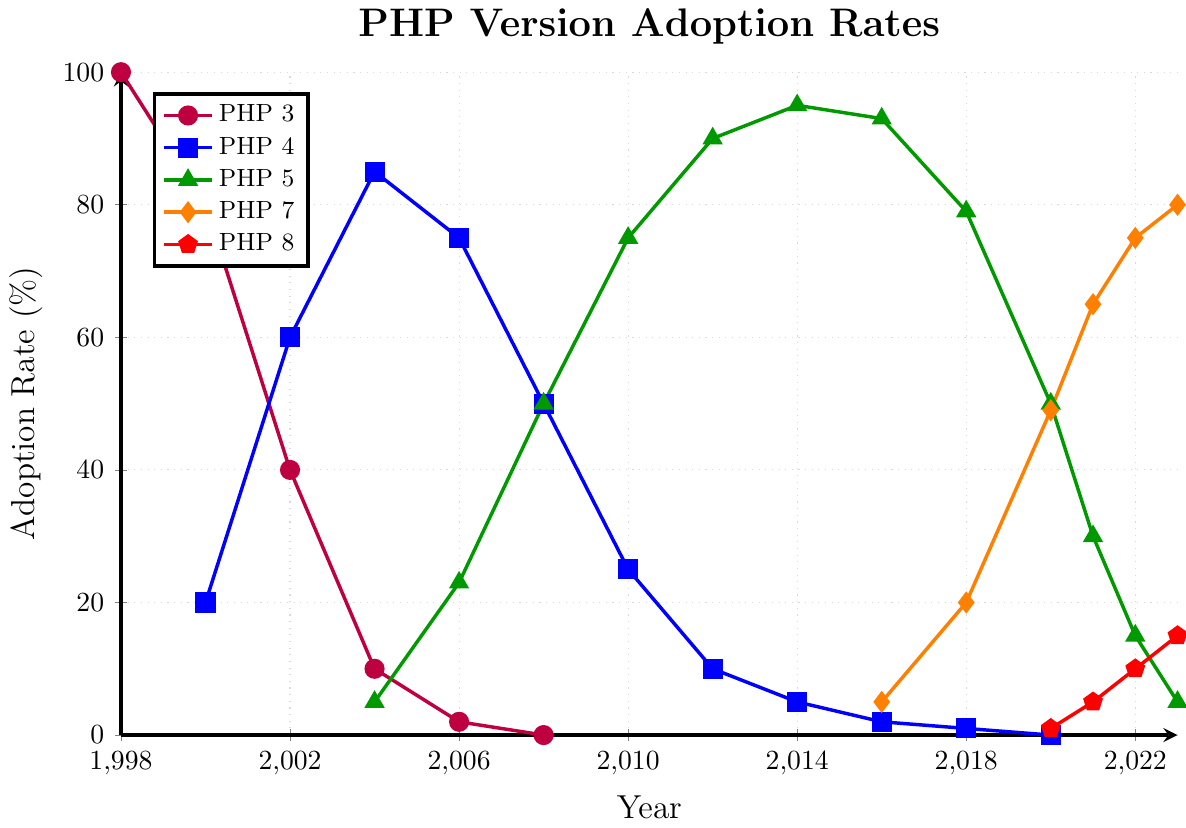What PHP version had the highest adoption rate in 2010? Look at the data point for the year 2010. PHP 5 has an adoption rate of 75%, which is higher than the others for that year.
Answer: PHP 5 How did the adoption rate of PHP 4 change from 2000 to 2010? Examine the data points for PHP 4 from 2000 to 2010. In 2000, it was 20%. By 2010, it decreased to 25%. The rate increased until 2004, then decreased more sharply after that.
Answer: Increased then decreased Which PHP version had a continuous increase from 2016 to 2023? Look for PHP versions which show increasing data points from 2016 to 2023. Only PHP 7 has a continuous increase starting from 5% in 2016 to 80% in 2023.
Answer: PHP 7 In which year did PHP 3 drop to 0% adoption? Look at the adoption rate of PHP 3 and identify the year it first reaches 0%. This occurred in the year 2008.
Answer: 2008 Compare the adoption rates of PHP 4 and PHP 5 in the year 2008. Which was higher? Look at the data points for the year 2008. PHP 4 had an adoption rate of 50%, whereas PHP 5 also had 50%. Both had the same adoption rate that year.
Answer: Equal What was the adoption rate of PHP 8 in 2022 compared to 2023? Look at the data points for PHP 8 in 2022 and 2023. It was 10% in 2022 and increased to 15% in 2023.
Answer: Increased What is the average adoption rate of PHP 4 from 2000 to 2010? Find the adoption rates of PHP 4 in each year from 2000 to 2010, sum them, and divide by the number of years: (20+60+85+75+50+25)/6 = 315/6 = 52.5%.
Answer: 52.5% In which year did PHP 5 have a peak adoption rate? Look at the data points for PHP 5. The highest value, 95%, occurred in the year 2014.
Answer: 2014 Between 2021 and 2022, which PHP version saw the greatest increase in adoption rate? Compare the increase in adoption rates for each PHP version between 2021 and 2022. PHP 7 increased from 65% to 75%, which is a 10% increase, the largest among all versions.
Answer: PHP 7 